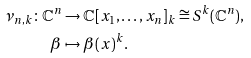Convert formula to latex. <formula><loc_0><loc_0><loc_500><loc_500>\nu _ { n , k } \colon \mathbb { C } ^ { n } & \to \mathbb { C } [ x _ { 1 } , \dots , x _ { n } ] _ { k } \cong S ^ { k } ( \mathbb { C } ^ { n } ) , \\ \beta & \mapsto \beta ( x ) ^ { k } .</formula> 